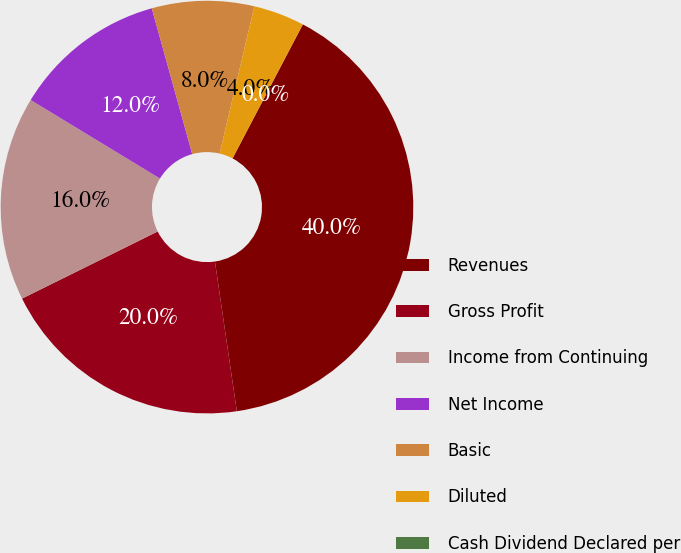Convert chart to OTSL. <chart><loc_0><loc_0><loc_500><loc_500><pie_chart><fcel>Revenues<fcel>Gross Profit<fcel>Income from Continuing<fcel>Net Income<fcel>Basic<fcel>Diluted<fcel>Cash Dividend Declared per<nl><fcel>40.0%<fcel>20.0%<fcel>16.0%<fcel>12.0%<fcel>8.0%<fcel>4.0%<fcel>0.0%<nl></chart> 